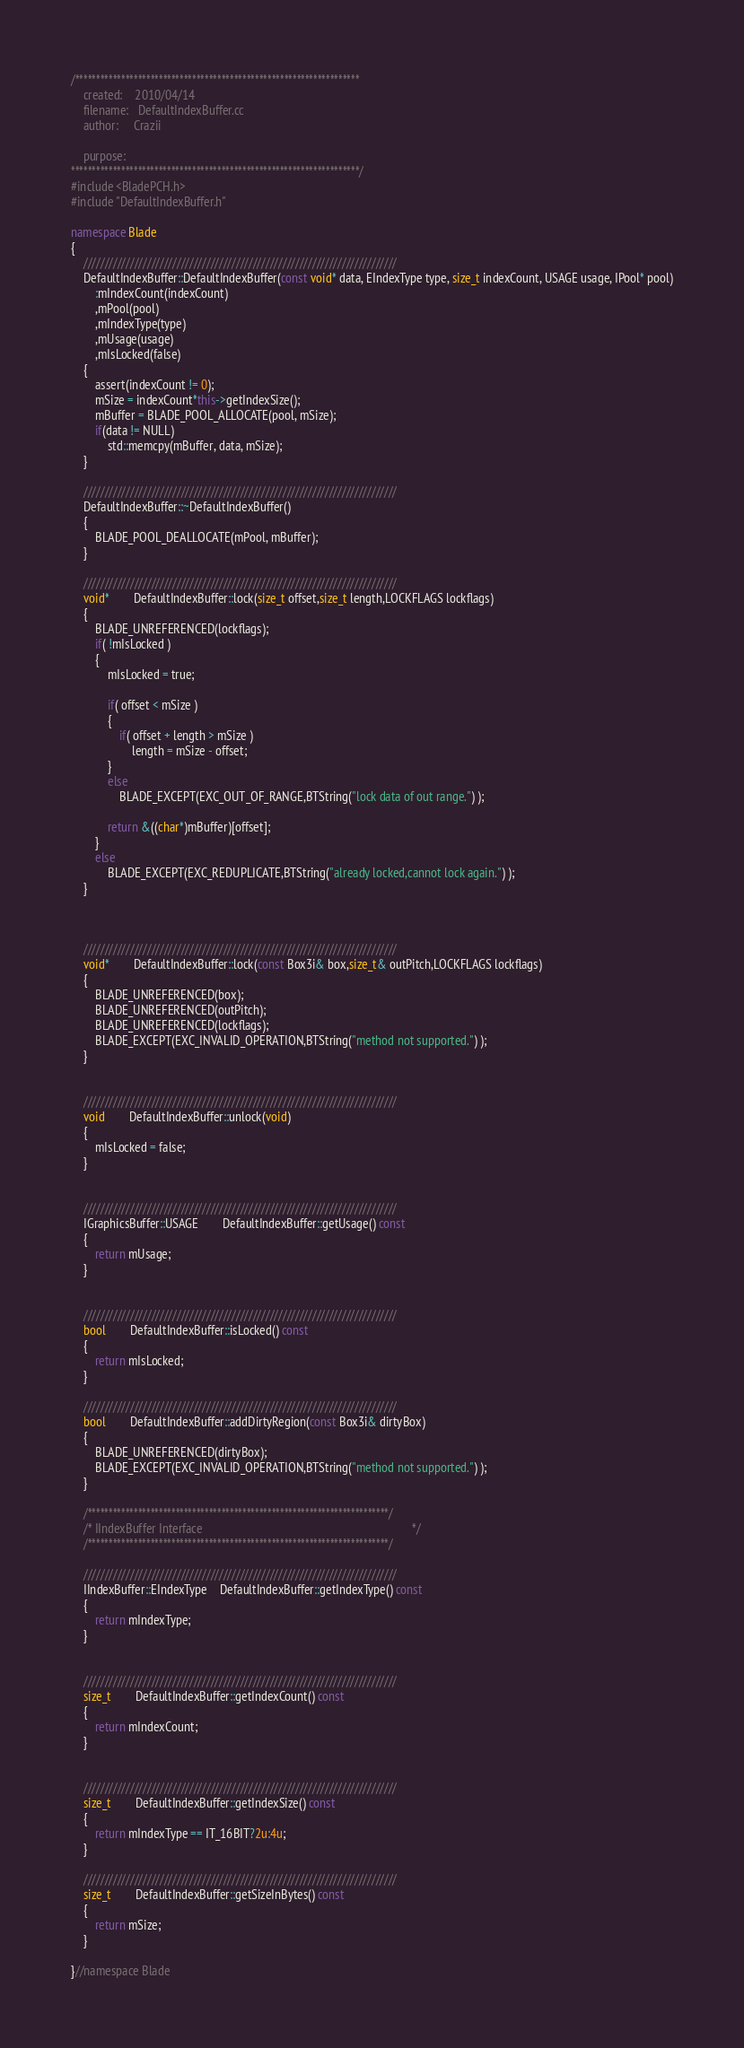<code> <loc_0><loc_0><loc_500><loc_500><_C++_>/********************************************************************
	created:	2010/04/14
	filename: 	DefaultIndexBuffer.cc
	author:		Crazii
	
	purpose:	
*********************************************************************/
#include <BladePCH.h>
#include "DefaultIndexBuffer.h"

namespace Blade
{
	//////////////////////////////////////////////////////////////////////////
	DefaultIndexBuffer::DefaultIndexBuffer(const void* data, EIndexType type, size_t indexCount, USAGE usage, IPool* pool)
		:mIndexCount(indexCount)
		,mPool(pool)
		,mIndexType(type)
		,mUsage(usage)
		,mIsLocked(false)
	{
		assert(indexCount != 0);
		mSize = indexCount*this->getIndexSize();
		mBuffer = BLADE_POOL_ALLOCATE(pool, mSize);
		if(data != NULL)
			std::memcpy(mBuffer, data, mSize);
	}

	//////////////////////////////////////////////////////////////////////////
	DefaultIndexBuffer::~DefaultIndexBuffer()
	{
		BLADE_POOL_DEALLOCATE(mPool, mBuffer);
	}

	//////////////////////////////////////////////////////////////////////////
	void*		DefaultIndexBuffer::lock(size_t offset,size_t length,LOCKFLAGS lockflags)
	{
		BLADE_UNREFERENCED(lockflags);
		if( !mIsLocked )
		{
			mIsLocked = true;

			if( offset < mSize )
			{
				if( offset + length > mSize )
					length = mSize - offset;
			}
			else
				BLADE_EXCEPT(EXC_OUT_OF_RANGE,BTString("lock data of out range.") );

			return &((char*)mBuffer)[offset];
		}
		else
			BLADE_EXCEPT(EXC_REDUPLICATE,BTString("already locked,cannot lock again.") );
	}



	//////////////////////////////////////////////////////////////////////////
	void*		DefaultIndexBuffer::lock(const Box3i& box,size_t& outPitch,LOCKFLAGS lockflags)
	{
		BLADE_UNREFERENCED(box);
		BLADE_UNREFERENCED(outPitch);
		BLADE_UNREFERENCED(lockflags);
		BLADE_EXCEPT(EXC_INVALID_OPERATION,BTString("method not supported.") );
	}


	//////////////////////////////////////////////////////////////////////////
	void		DefaultIndexBuffer::unlock(void)
	{
		mIsLocked = false;
	}


	//////////////////////////////////////////////////////////////////////////
	IGraphicsBuffer::USAGE		DefaultIndexBuffer::getUsage() const
	{
		return mUsage;
	}


	//////////////////////////////////////////////////////////////////////////
	bool		DefaultIndexBuffer::isLocked() const
	{
		return mIsLocked;
	}

	//////////////////////////////////////////////////////////////////////////
	bool		DefaultIndexBuffer::addDirtyRegion(const Box3i& dirtyBox)
	{
		BLADE_UNREFERENCED(dirtyBox);
		BLADE_EXCEPT(EXC_INVALID_OPERATION,BTString("method not supported.") );
	}

	/************************************************************************/
	/* IIndexBuffer Interface                                                                     */
	/************************************************************************/

	//////////////////////////////////////////////////////////////////////////
	IIndexBuffer::EIndexType	DefaultIndexBuffer::getIndexType() const
	{
		return mIndexType;
	}


	//////////////////////////////////////////////////////////////////////////
	size_t		DefaultIndexBuffer::getIndexCount() const
	{
		return mIndexCount;
	}


	//////////////////////////////////////////////////////////////////////////
	size_t		DefaultIndexBuffer::getIndexSize() const
	{
		return mIndexType == IT_16BIT?2u:4u;
	}

	//////////////////////////////////////////////////////////////////////////
	size_t		DefaultIndexBuffer::getSizeInBytes() const
	{
		return mSize;
	}
	
}//namespace Blade</code> 